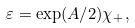Convert formula to latex. <formula><loc_0><loc_0><loc_500><loc_500>\varepsilon = \exp ( A / 2 ) \chi _ { + } ,</formula> 